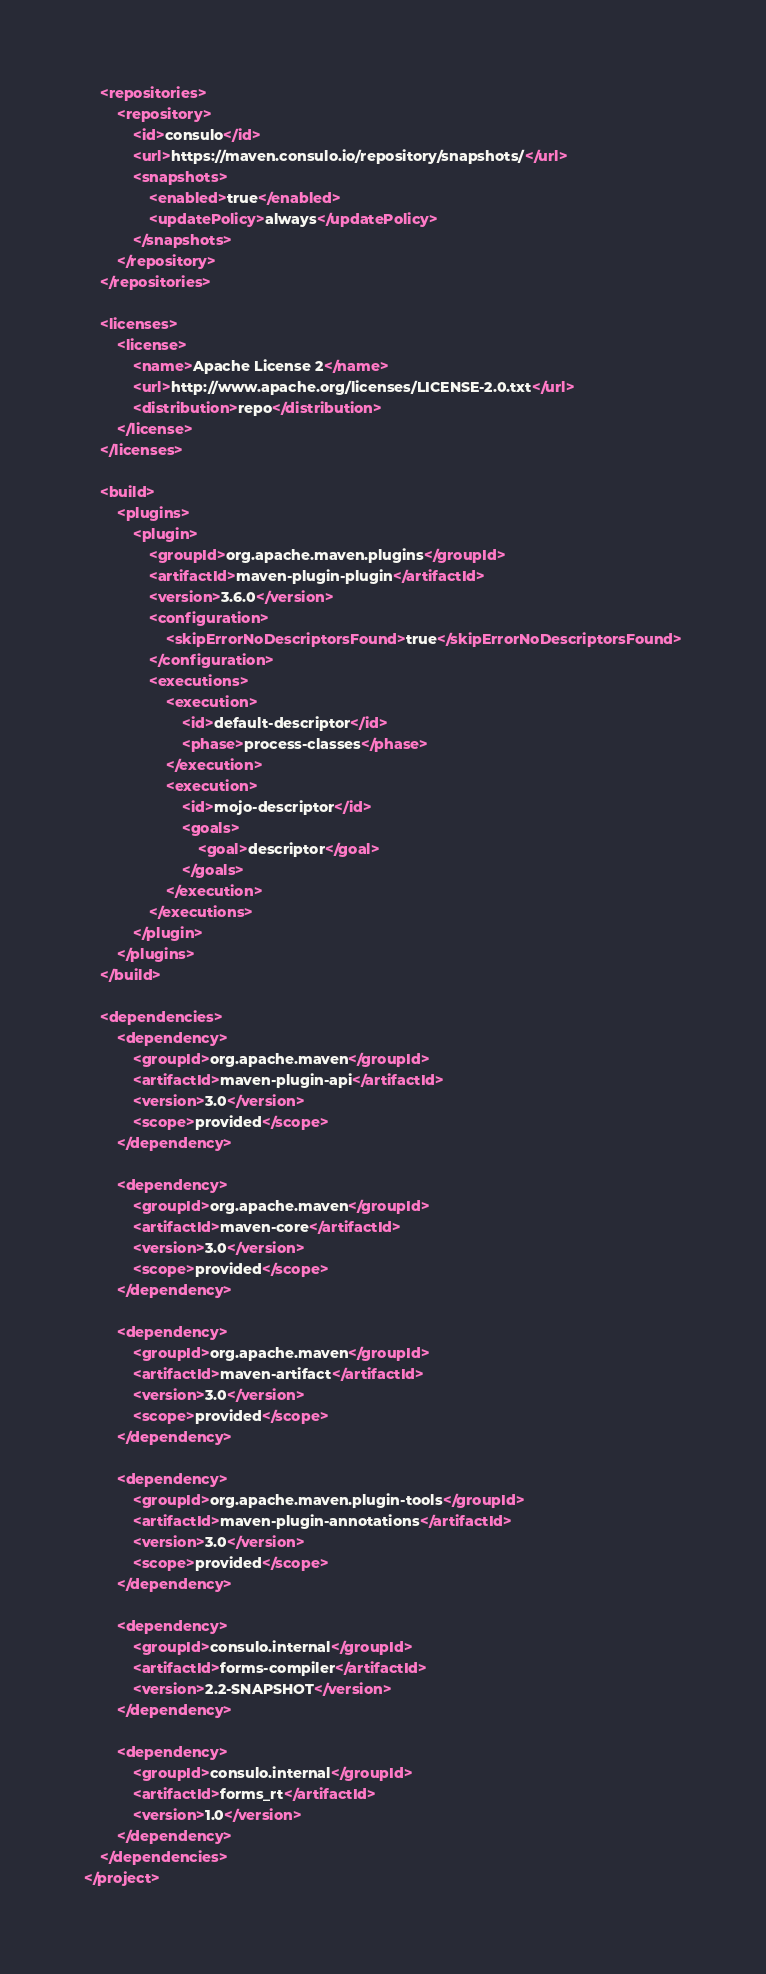Convert code to text. <code><loc_0><loc_0><loc_500><loc_500><_XML_>	<repositories>
		<repository>
			<id>consulo</id>
			<url>https://maven.consulo.io/repository/snapshots/</url>
			<snapshots>
				<enabled>true</enabled>
				<updatePolicy>always</updatePolicy>
			</snapshots>
		</repository>
	</repositories>

	<licenses>
		<license>
			<name>Apache License 2</name>
			<url>http://www.apache.org/licenses/LICENSE-2.0.txt</url>
			<distribution>repo</distribution>
		</license>
	</licenses>

	<build>
		<plugins>
			<plugin>
				<groupId>org.apache.maven.plugins</groupId>
				<artifactId>maven-plugin-plugin</artifactId>
				<version>3.6.0</version>
				<configuration>
					<skipErrorNoDescriptorsFound>true</skipErrorNoDescriptorsFound>
				</configuration>
				<executions>
					<execution>
						<id>default-descriptor</id>
						<phase>process-classes</phase>
					</execution>
					<execution>
						<id>mojo-descriptor</id>
						<goals>
							<goal>descriptor</goal>
						</goals>
					</execution>
				</executions>
			</plugin>
		</plugins>
	</build>

	<dependencies>
		<dependency>
			<groupId>org.apache.maven</groupId>
			<artifactId>maven-plugin-api</artifactId>
			<version>3.0</version>
			<scope>provided</scope>
		</dependency>

		<dependency>
			<groupId>org.apache.maven</groupId>
			<artifactId>maven-core</artifactId>
			<version>3.0</version>
			<scope>provided</scope>
		</dependency>

		<dependency>
			<groupId>org.apache.maven</groupId>
			<artifactId>maven-artifact</artifactId>
			<version>3.0</version>
			<scope>provided</scope>
		</dependency>

		<dependency>
			<groupId>org.apache.maven.plugin-tools</groupId>
			<artifactId>maven-plugin-annotations</artifactId>
			<version>3.0</version>
			<scope>provided</scope>
		</dependency>

		<dependency>
			<groupId>consulo.internal</groupId>
			<artifactId>forms-compiler</artifactId>
			<version>2.2-SNAPSHOT</version>
		</dependency>

		<dependency>
			<groupId>consulo.internal</groupId>
			<artifactId>forms_rt</artifactId>
			<version>1.0</version>
		</dependency>
	</dependencies>
</project>
</code> 